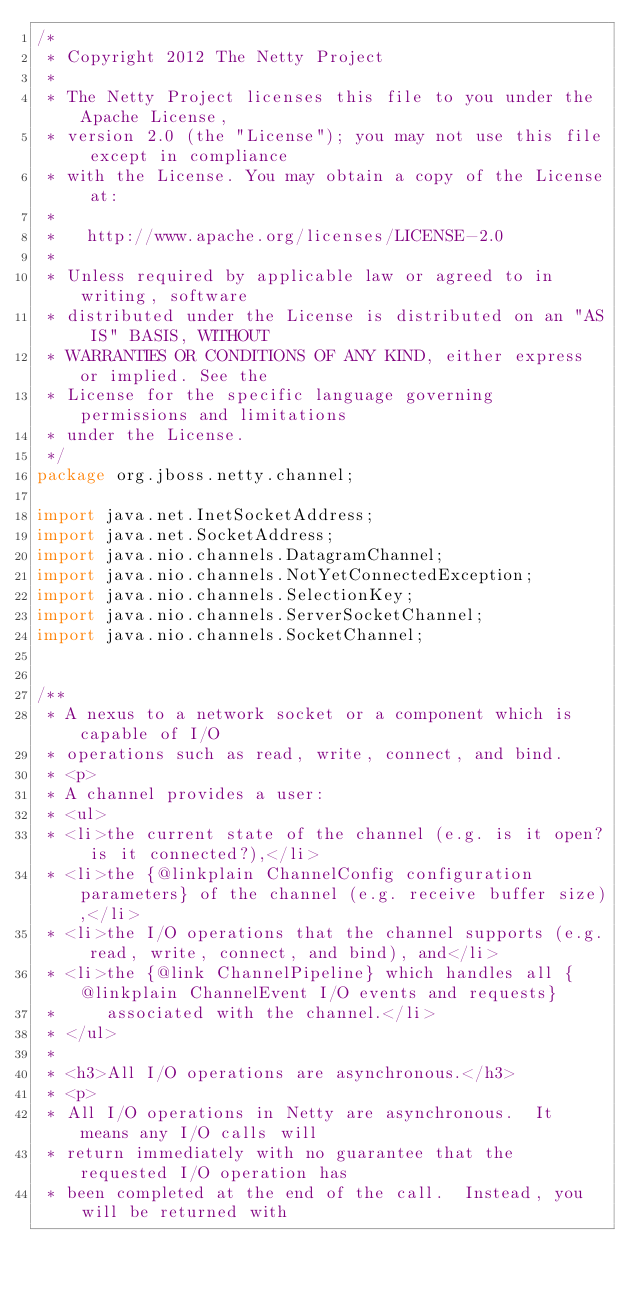<code> <loc_0><loc_0><loc_500><loc_500><_Java_>/*
 * Copyright 2012 The Netty Project
 *
 * The Netty Project licenses this file to you under the Apache License,
 * version 2.0 (the "License"); you may not use this file except in compliance
 * with the License. You may obtain a copy of the License at:
 *
 *   http://www.apache.org/licenses/LICENSE-2.0
 *
 * Unless required by applicable law or agreed to in writing, software
 * distributed under the License is distributed on an "AS IS" BASIS, WITHOUT
 * WARRANTIES OR CONDITIONS OF ANY KIND, either express or implied. See the
 * License for the specific language governing permissions and limitations
 * under the License.
 */
package org.jboss.netty.channel;

import java.net.InetSocketAddress;
import java.net.SocketAddress;
import java.nio.channels.DatagramChannel;
import java.nio.channels.NotYetConnectedException;
import java.nio.channels.SelectionKey;
import java.nio.channels.ServerSocketChannel;
import java.nio.channels.SocketChannel;


/**
 * A nexus to a network socket or a component which is capable of I/O
 * operations such as read, write, connect, and bind.
 * <p>
 * A channel provides a user:
 * <ul>
 * <li>the current state of the channel (e.g. is it open? is it connected?),</li>
 * <li>the {@linkplain ChannelConfig configuration parameters} of the channel (e.g. receive buffer size),</li>
 * <li>the I/O operations that the channel supports (e.g. read, write, connect, and bind), and</li>
 * <li>the {@link ChannelPipeline} which handles all {@linkplain ChannelEvent I/O events and requests}
 *     associated with the channel.</li>
 * </ul>
 *
 * <h3>All I/O operations are asynchronous.</h3>
 * <p>
 * All I/O operations in Netty are asynchronous.  It means any I/O calls will
 * return immediately with no guarantee that the requested I/O operation has
 * been completed at the end of the call.  Instead, you will be returned with</code> 